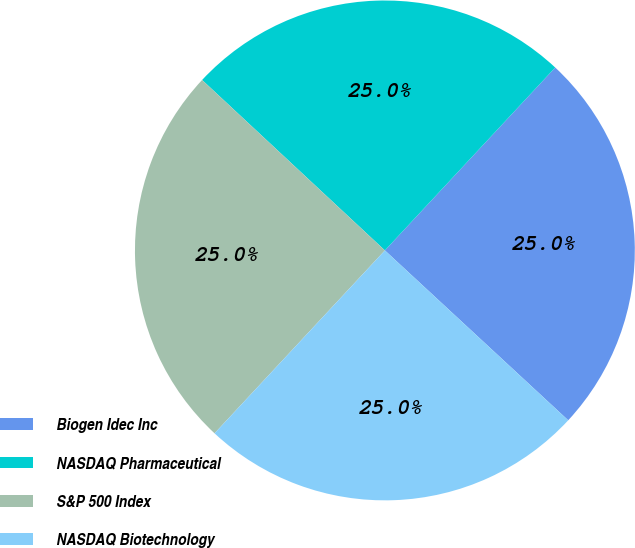Convert chart to OTSL. <chart><loc_0><loc_0><loc_500><loc_500><pie_chart><fcel>Biogen Idec Inc<fcel>NASDAQ Pharmaceutical<fcel>S&P 500 Index<fcel>NASDAQ Biotechnology<nl><fcel>24.96%<fcel>24.99%<fcel>25.01%<fcel>25.04%<nl></chart> 